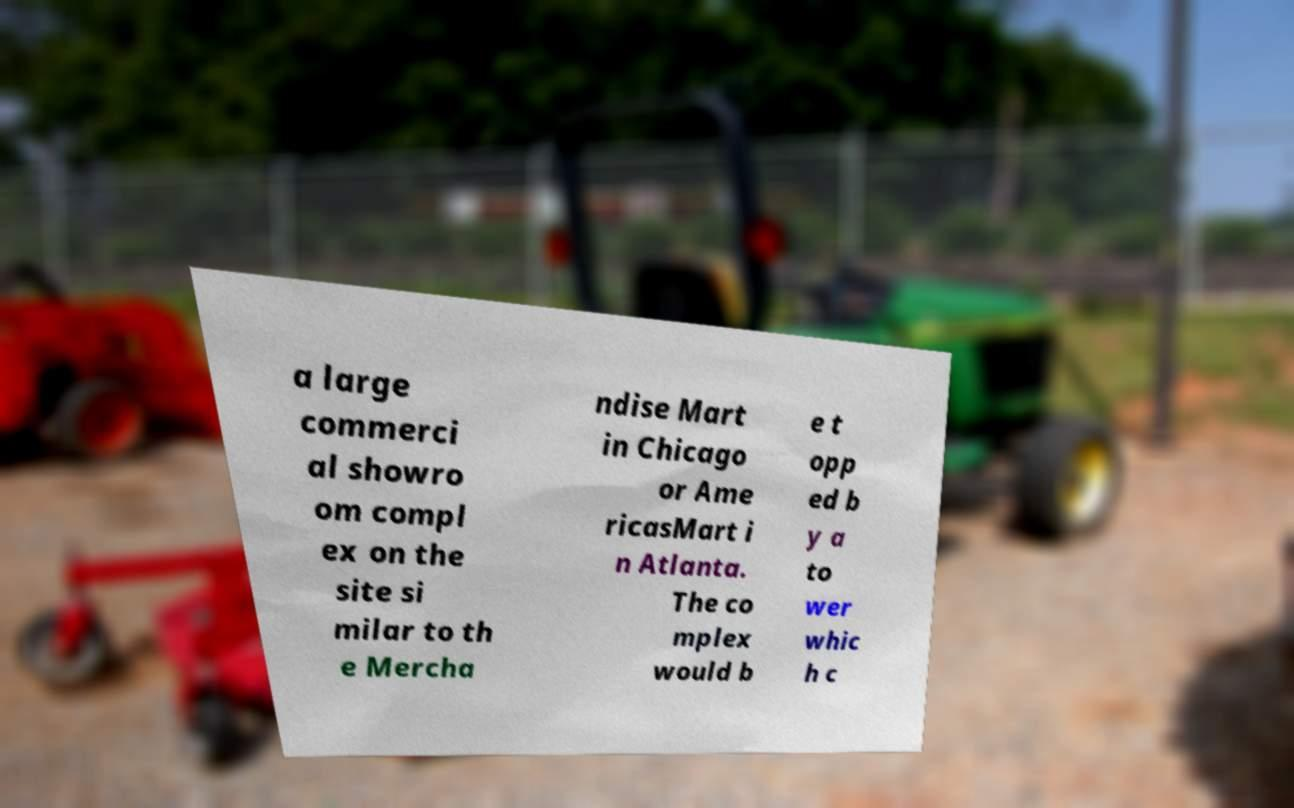What messages or text are displayed in this image? I need them in a readable, typed format. a large commerci al showro om compl ex on the site si milar to th e Mercha ndise Mart in Chicago or Ame ricasMart i n Atlanta. The co mplex would b e t opp ed b y a to wer whic h c 